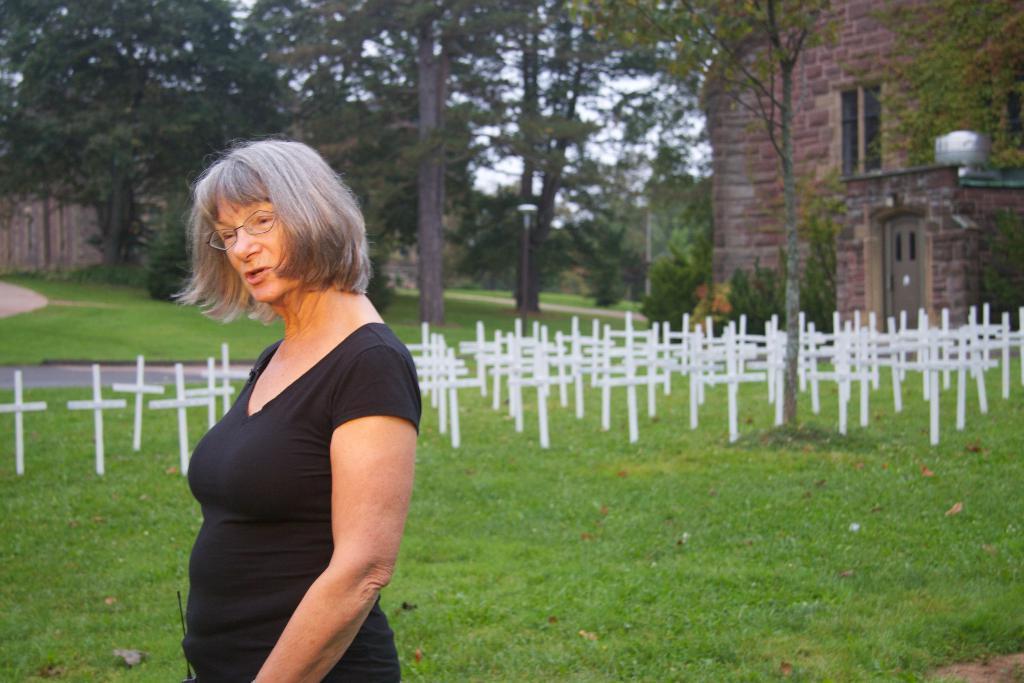Could you give a brief overview of what you see in this image? In this image we can see these women wearing black t-shirt and spectacles is standing here. Here we can see the grassland, cross symbols, trees, brick house and the sky in the background. 